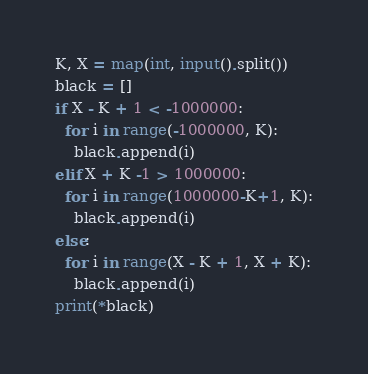Convert code to text. <code><loc_0><loc_0><loc_500><loc_500><_Python_>K, X = map(int, input().split())
black = []
if X - K + 1 < -1000000:
  for i in range(-1000000, K):
    black.append(i)
elif X + K -1 > 1000000:
  for i in range(1000000-K+1, K):
    black.append(i)
else:
  for i in range(X - K + 1, X + K):
    black.append(i)
print(*black)</code> 